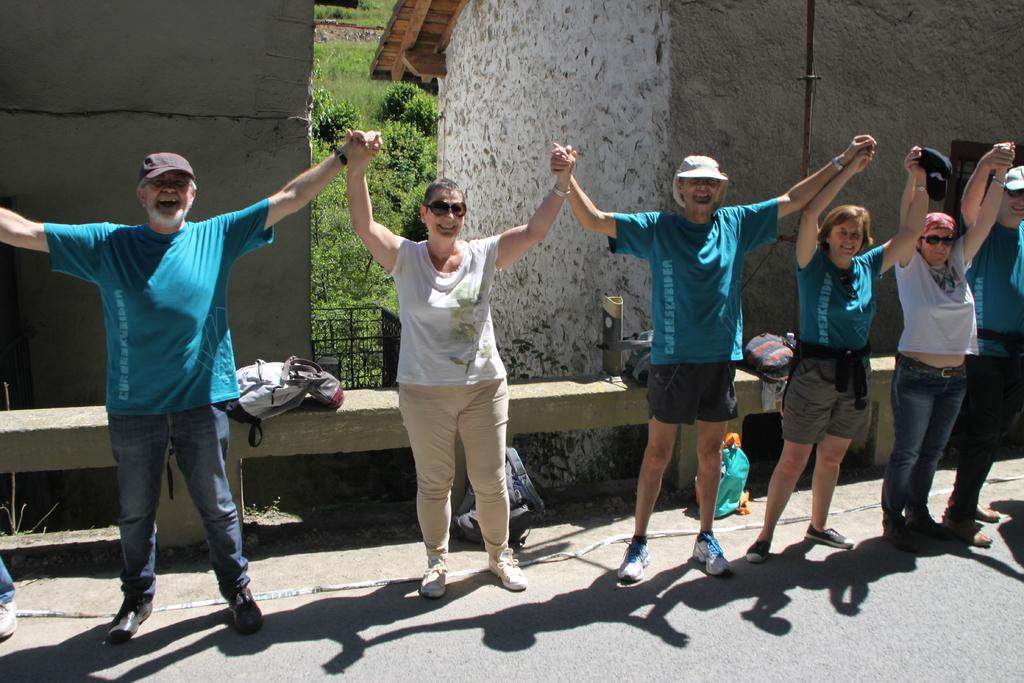What are the people in the image doing? There is a group of persons standing on the road in the image. What can be seen in the background of the image? There are buildings, trees, and grass in the background of the image. What type of cork can be seen in the image? There is no cork present in the image. What type of dirt is visible on the road in the image? The image does not show any dirt on the road; it only shows a group of persons standing on the road. 